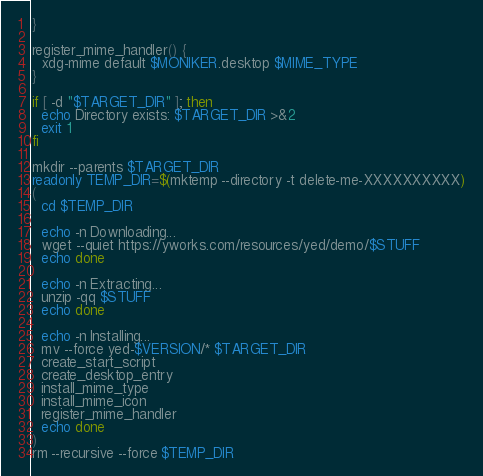Convert code to text. <code><loc_0><loc_0><loc_500><loc_500><_Bash_>}

register_mime_handler() {
  xdg-mime default $MONIKER.desktop $MIME_TYPE
}

if [ -d "$TARGET_DIR" ]; then
  echo Directory exists: $TARGET_DIR >&2
  exit 1
fi

mkdir --parents $TARGET_DIR
readonly TEMP_DIR=$(mktemp --directory -t delete-me-XXXXXXXXXX)
(
  cd $TEMP_DIR

  echo -n Downloading...
  wget --quiet https://yworks.com/resources/yed/demo/$STUFF
  echo done

  echo -n Extracting...
  unzip -qq $STUFF
  echo done

  echo -n Installing...
  mv --force yed-$VERSION/* $TARGET_DIR
  create_start_script
  create_desktop_entry
  install_mime_type
  install_mime_icon
  register_mime_handler
  echo done
)
rm --recursive --force $TEMP_DIR
</code> 